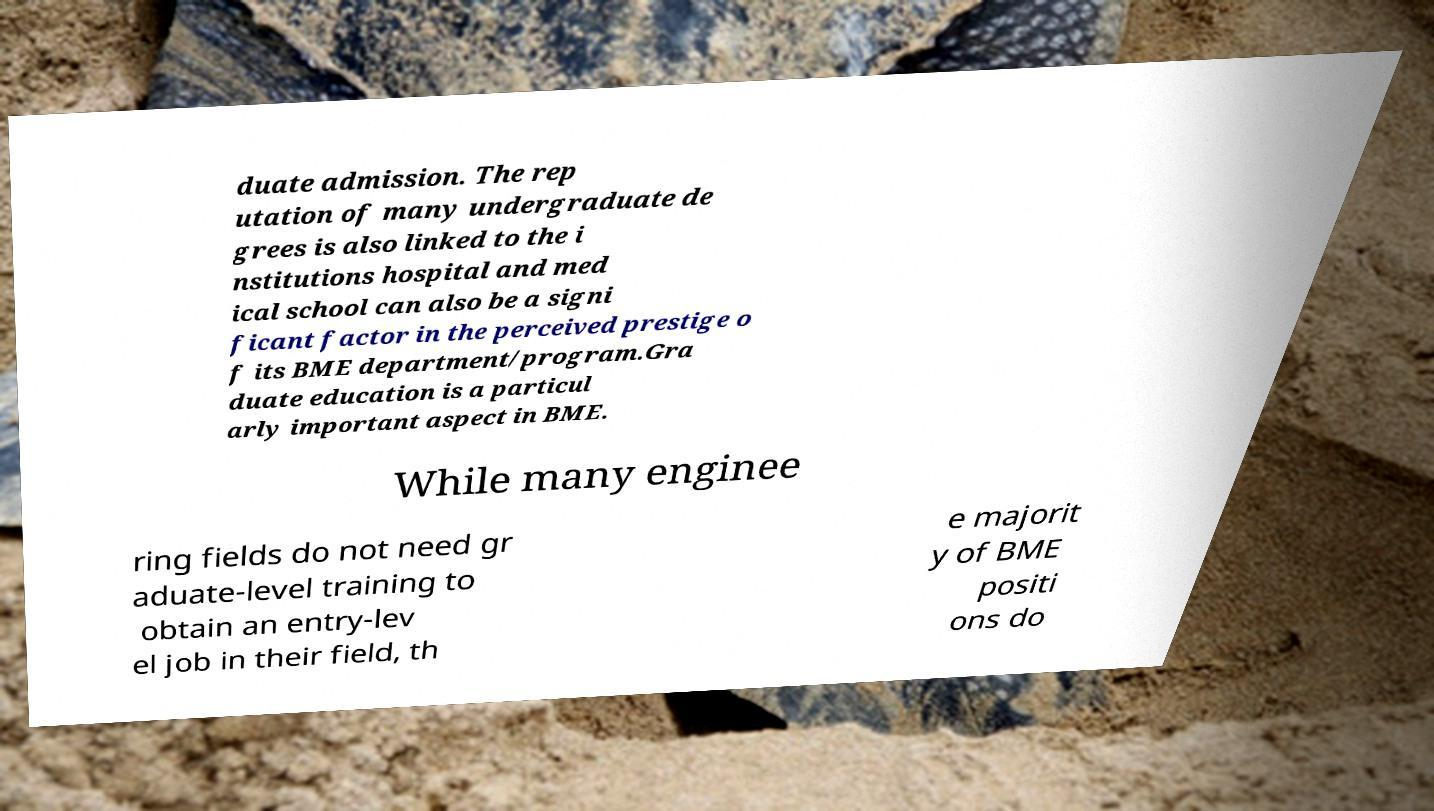What messages or text are displayed in this image? I need them in a readable, typed format. duate admission. The rep utation of many undergraduate de grees is also linked to the i nstitutions hospital and med ical school can also be a signi ficant factor in the perceived prestige o f its BME department/program.Gra duate education is a particul arly important aspect in BME. While many enginee ring fields do not need gr aduate-level training to obtain an entry-lev el job in their field, th e majorit y of BME positi ons do 